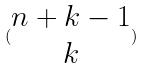Convert formula to latex. <formula><loc_0><loc_0><loc_500><loc_500>( \begin{matrix} n + k - 1 \\ k \end{matrix} )</formula> 